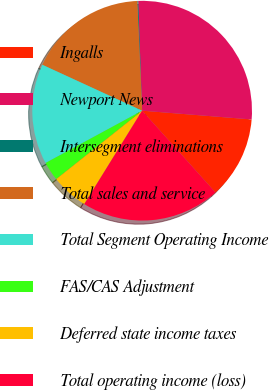<chart> <loc_0><loc_0><loc_500><loc_500><pie_chart><fcel>Ingalls<fcel>Newport News<fcel>Intersegment eliminations<fcel>Total sales and service<fcel>Total Segment Operating Income<fcel>FAS/CAS Adjustment<fcel>Deferred state income taxes<fcel>Total operating income (loss)<nl><fcel>12.09%<fcel>26.84%<fcel>0.13%<fcel>17.43%<fcel>14.76%<fcel>2.8%<fcel>5.47%<fcel>20.46%<nl></chart> 